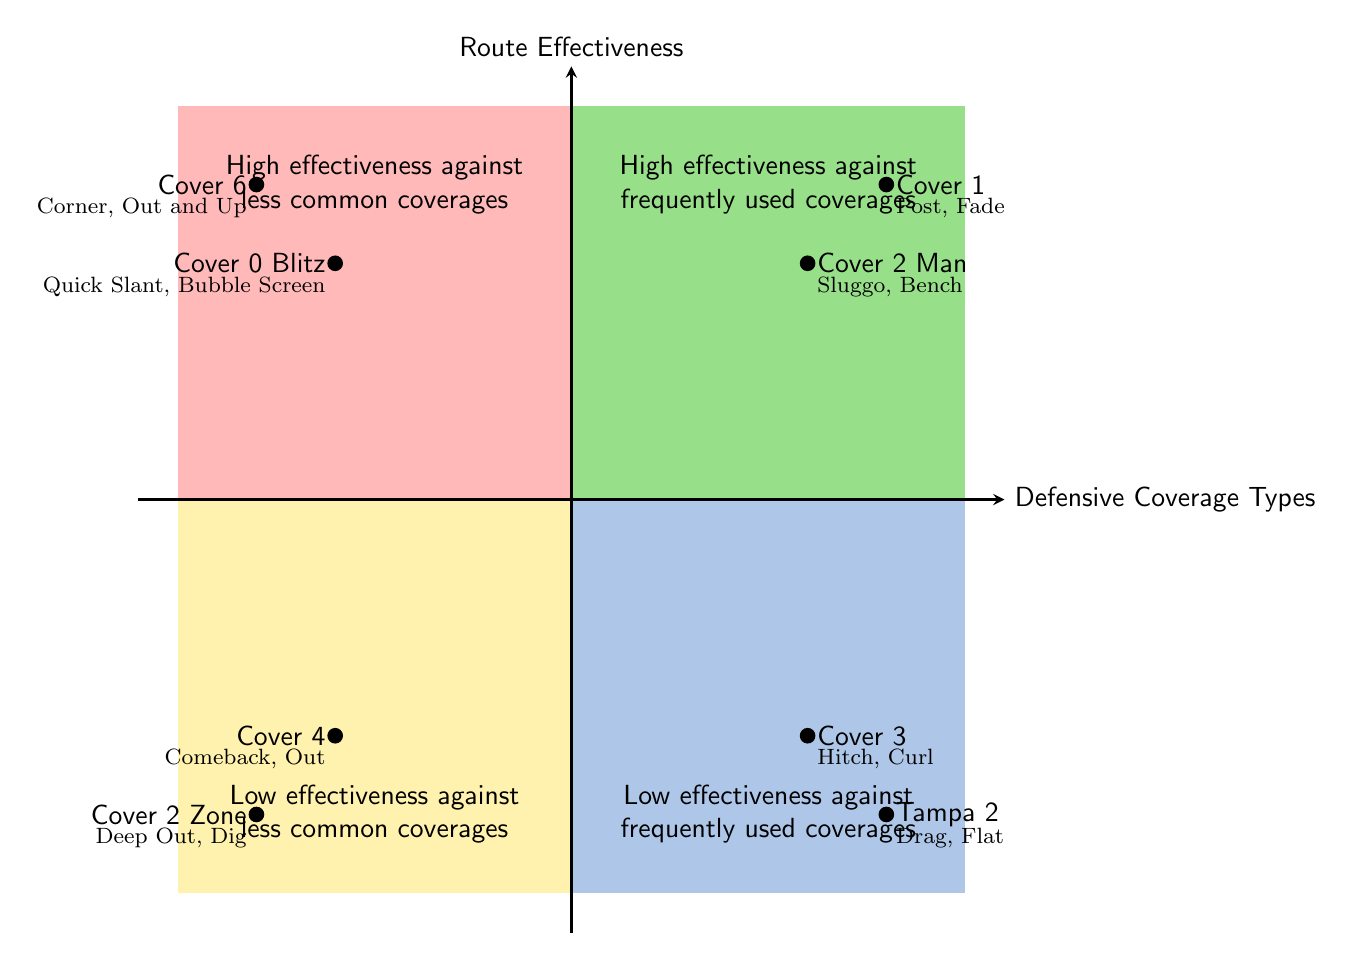What's in the top-right quadrant? The top-right quadrant contains "Cover 2 Man" and "Cover 1." This is determined by locating the quadrant on the diagram and checking the elements listed within it.
Answer: Cover 2 Man, Cover 1 What routes are effective against Cover 1? According to the top-right quadrant, the routes effective against "Cover 1" are "Post Route" and "Fade Route." These routes are listed next to that coverage in the quadrant.
Answer: Post Route, Fade Route Which defensive coverage has low effectiveness against frequently used coverages? In the bottom-right quadrant, we find "Cover 3" and "Tampa 2," indicating that these coverages have low effectiveness. Thus, they belong to the specified quadrant.
Answer: Cover 3, Tampa 2 What routes are effective against less common coverages? The top-left quadrant describes effectiveness against less common coverages, which includes "Quick Slant" and "Bubble Screen," listed under "Cover 0 Blitz" and "Corner Route" and "Out and Up" under "Cover 6."
Answer: Quick Slant, Bubble Screen, Corner Route, Out and Up Which coverage and routes are associated with low effectiveness against less common coverages? The bottom-left quadrant highlights "Cover 4" and "Cover 2 Zone." The associated routes listed are "Comeback Route," "Out Route," "Deep Out," and "Dig Route." Conclusively, these are found in that quadrant.
Answer: Cover 4, Cover 2 Zone, Comeback Route, Out Route, Deep Out, Dig Route 